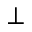<formula> <loc_0><loc_0><loc_500><loc_500>_ { \perp }</formula> 